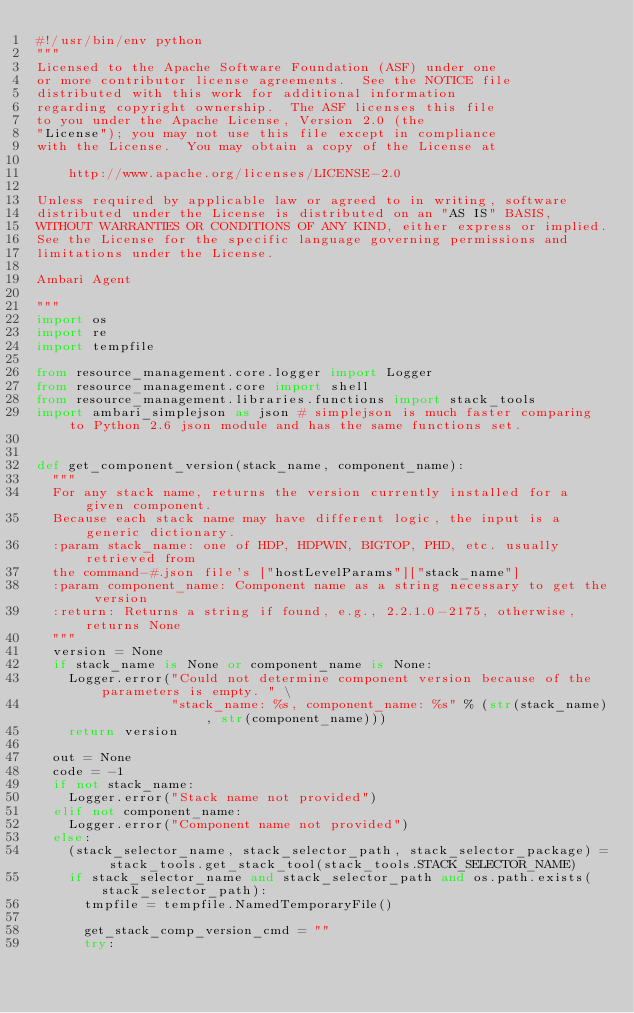Convert code to text. <code><loc_0><loc_0><loc_500><loc_500><_Python_>#!/usr/bin/env python
"""
Licensed to the Apache Software Foundation (ASF) under one
or more contributor license agreements.  See the NOTICE file
distributed with this work for additional information
regarding copyright ownership.  The ASF licenses this file
to you under the Apache License, Version 2.0 (the
"License"); you may not use this file except in compliance
with the License.  You may obtain a copy of the License at

    http://www.apache.org/licenses/LICENSE-2.0

Unless required by applicable law or agreed to in writing, software
distributed under the License is distributed on an "AS IS" BASIS,
WITHOUT WARRANTIES OR CONDITIONS OF ANY KIND, either express or implied.
See the License for the specific language governing permissions and
limitations under the License.

Ambari Agent

"""
import os
import re
import tempfile

from resource_management.core.logger import Logger
from resource_management.core import shell
from resource_management.libraries.functions import stack_tools
import ambari_simplejson as json # simplejson is much faster comparing to Python 2.6 json module and has the same functions set.


def get_component_version(stack_name, component_name):
  """
  For any stack name, returns the version currently installed for a given component.
  Because each stack name may have different logic, the input is a generic dictionary.
  :param stack_name: one of HDP, HDPWIN, BIGTOP, PHD, etc. usually retrieved from
  the command-#.json file's ["hostLevelParams"]["stack_name"]
  :param component_name: Component name as a string necessary to get the version
  :return: Returns a string if found, e.g., 2.2.1.0-2175, otherwise, returns None
  """
  version = None
  if stack_name is None or component_name is None:
    Logger.error("Could not determine component version because of the parameters is empty. " \
                 "stack_name: %s, component_name: %s" % (str(stack_name), str(component_name)))
    return version

  out = None
  code = -1
  if not stack_name:
    Logger.error("Stack name not provided")
  elif not component_name:
    Logger.error("Component name not provided")
  else:
    (stack_selector_name, stack_selector_path, stack_selector_package) = stack_tools.get_stack_tool(stack_tools.STACK_SELECTOR_NAME)
    if stack_selector_name and stack_selector_path and os.path.exists(stack_selector_path):
      tmpfile = tempfile.NamedTemporaryFile()

      get_stack_comp_version_cmd = ""
      try:</code> 